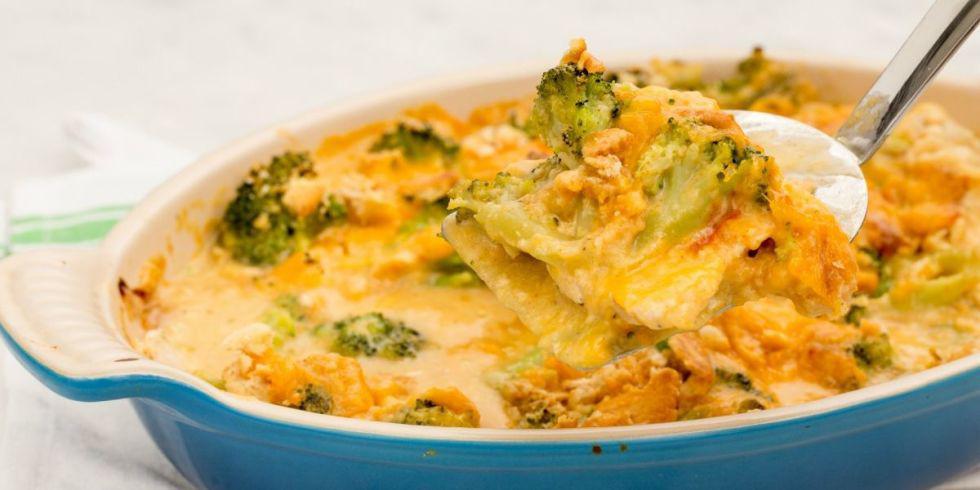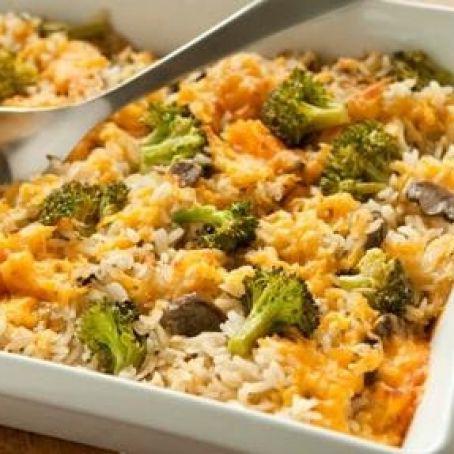The first image is the image on the left, the second image is the image on the right. Given the left and right images, does the statement "The casserole sits in a blue and white dish in one of the images." hold true? Answer yes or no. Yes. The first image is the image on the left, the second image is the image on the right. Assess this claim about the two images: "Right image shows a casserole served in a white squarish dish, with a silver serving utensil.". Correct or not? Answer yes or no. Yes. 